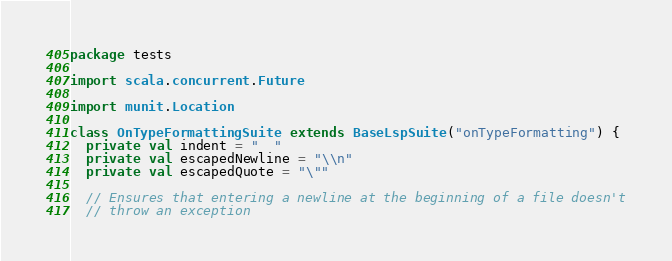<code> <loc_0><loc_0><loc_500><loc_500><_Scala_>package tests

import scala.concurrent.Future

import munit.Location

class OnTypeFormattingSuite extends BaseLspSuite("onTypeFormatting") {
  private val indent = "  "
  private val escapedNewline = "\\n"
  private val escapedQuote = "\""

  // Ensures that entering a newline at the beginning of a file doesn't
  // throw an exception</code> 